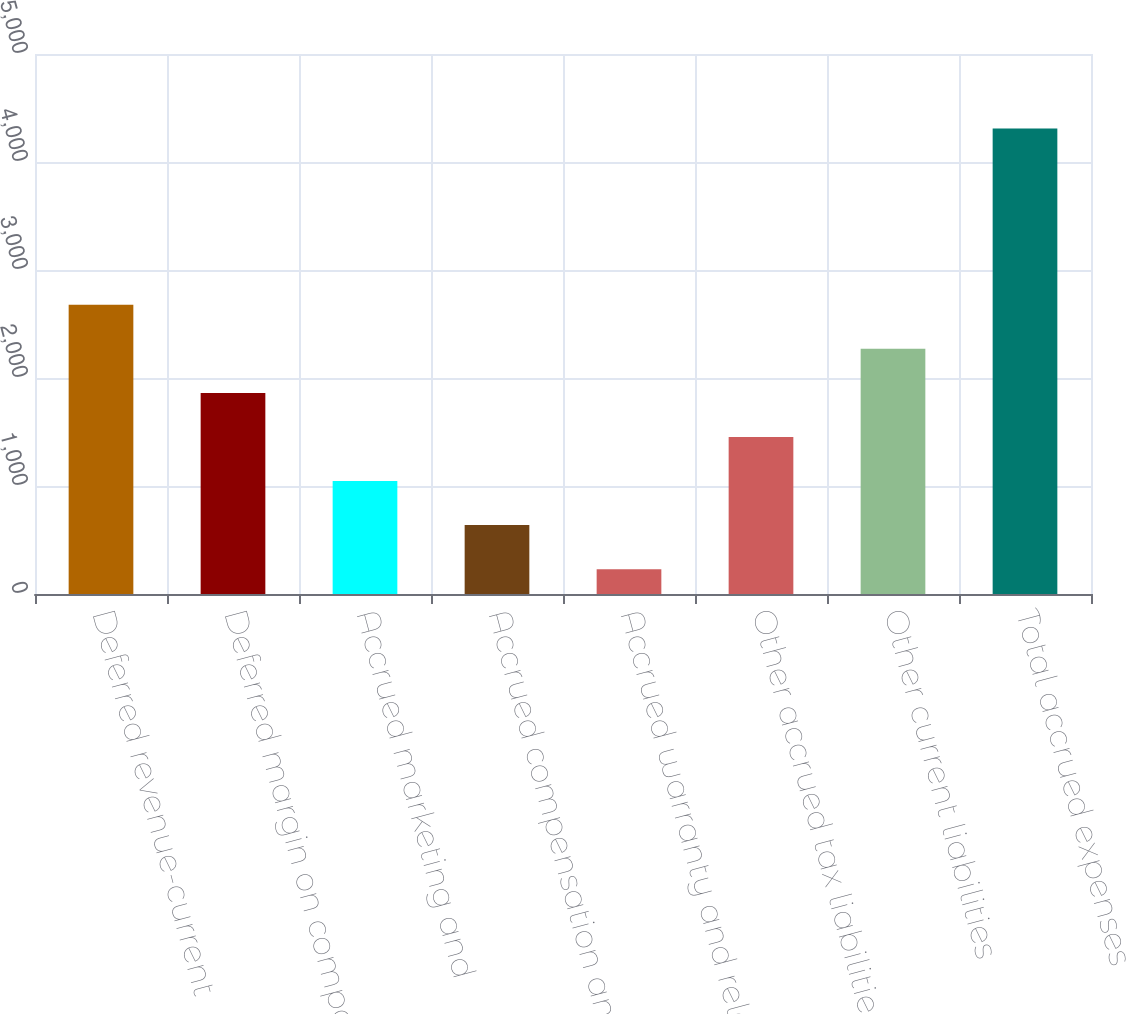<chart> <loc_0><loc_0><loc_500><loc_500><bar_chart><fcel>Deferred revenue-current<fcel>Deferred margin on component<fcel>Accrued marketing and<fcel>Accrued compensation and<fcel>Accrued warranty and related<fcel>Other accrued tax liabilities<fcel>Other current liabilities<fcel>Total accrued expenses<nl><fcel>2678<fcel>1862<fcel>1046<fcel>638<fcel>230<fcel>1454<fcel>2270<fcel>4310<nl></chart> 